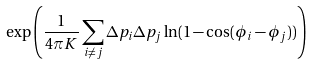<formula> <loc_0><loc_0><loc_500><loc_500>\exp \left ( \frac { 1 } { 4 \pi K } \sum _ { i \neq j } \Delta p _ { i } \Delta p _ { j } \ln ( 1 - \cos ( \phi _ { i } - \phi _ { j } ) ) \right )</formula> 